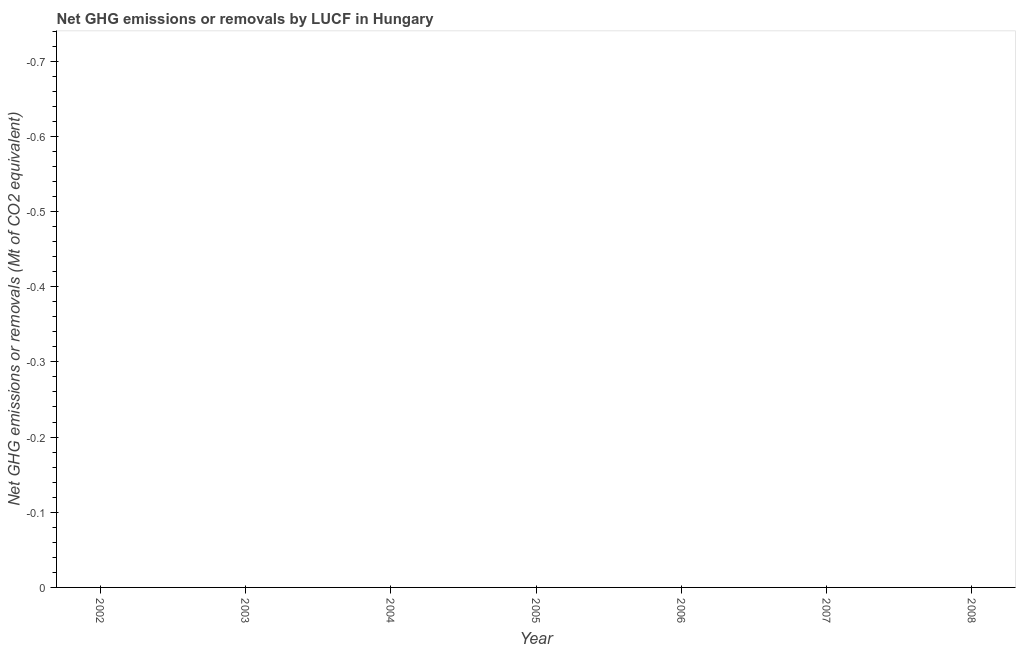What is the ghg net emissions or removals in 2006?
Provide a short and direct response. 0. Across all years, what is the minimum ghg net emissions or removals?
Your answer should be compact. 0. What is the sum of the ghg net emissions or removals?
Ensure brevity in your answer.  0. What is the average ghg net emissions or removals per year?
Ensure brevity in your answer.  0. In how many years, is the ghg net emissions or removals greater than -0.34 Mt?
Your answer should be compact. 0. Does the ghg net emissions or removals monotonically increase over the years?
Your answer should be compact. No. How many dotlines are there?
Your answer should be very brief. 0. How many years are there in the graph?
Provide a succinct answer. 7. What is the difference between two consecutive major ticks on the Y-axis?
Provide a short and direct response. 0.1. Does the graph contain any zero values?
Provide a short and direct response. Yes. What is the title of the graph?
Make the answer very short. Net GHG emissions or removals by LUCF in Hungary. What is the label or title of the Y-axis?
Keep it short and to the point. Net GHG emissions or removals (Mt of CO2 equivalent). What is the Net GHG emissions or removals (Mt of CO2 equivalent) in 2003?
Make the answer very short. 0. What is the Net GHG emissions or removals (Mt of CO2 equivalent) in 2004?
Your response must be concise. 0. What is the Net GHG emissions or removals (Mt of CO2 equivalent) in 2005?
Provide a succinct answer. 0. What is the Net GHG emissions or removals (Mt of CO2 equivalent) in 2007?
Keep it short and to the point. 0. 